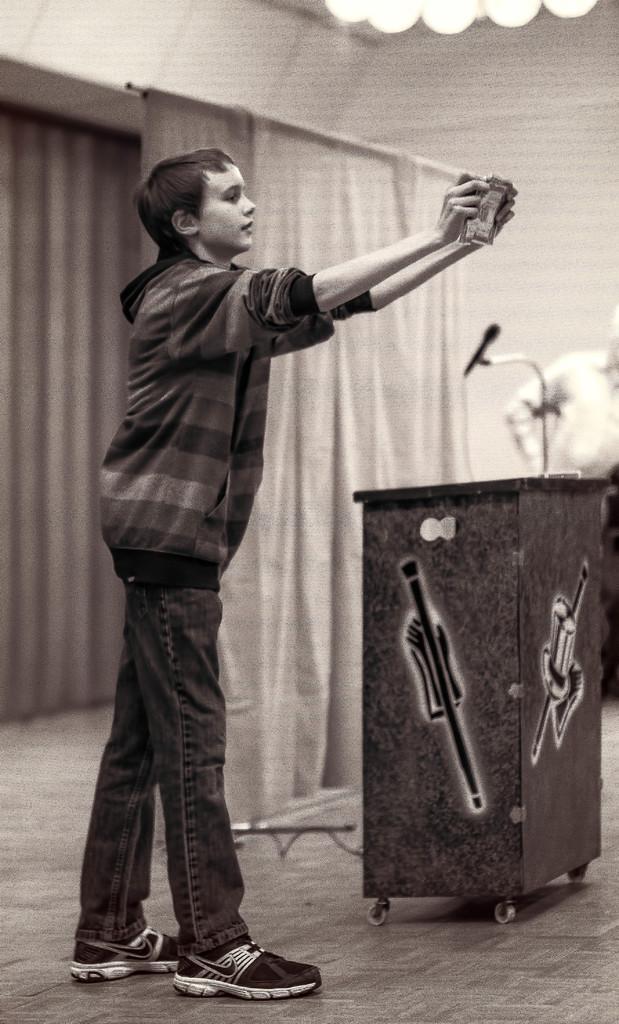Please provide a concise description of this image. In this image we can see a boy standing on the ground. Holding a book in his hand. In the background we can see a podium ,curtain and a person. 